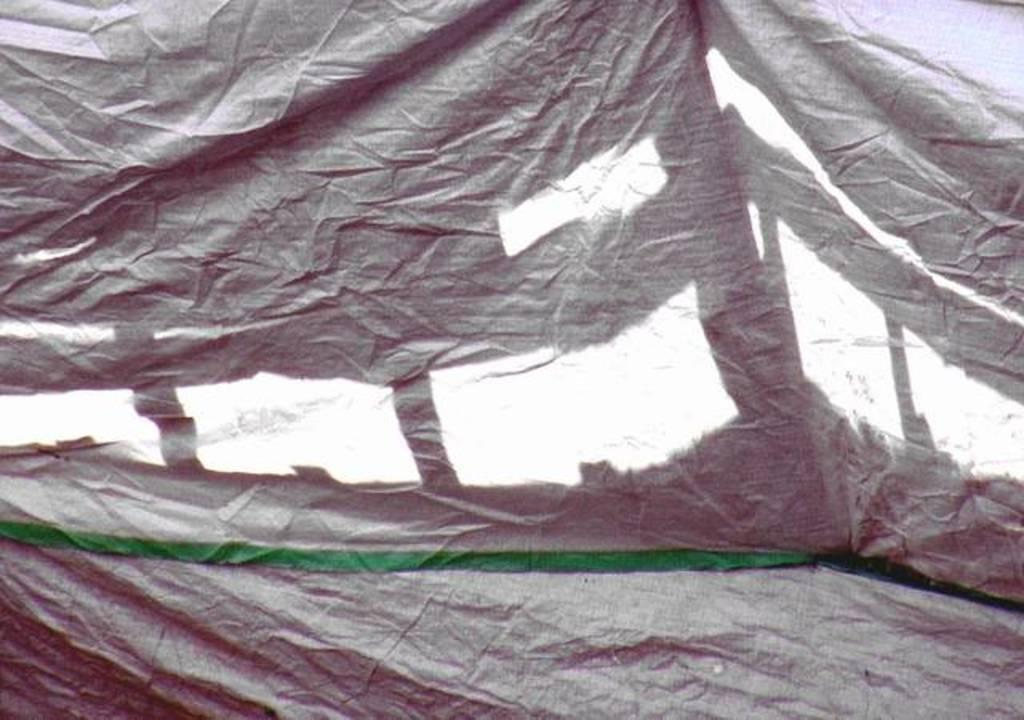What is present in the image that can be used to cover something? There is a cover in the image. What color is the cover? The cover is black. Does the cover have a tail in the image? No, the cover does not have a tail in the image, as covers are not living beings and do not possess body parts like tails. 